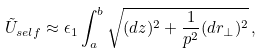Convert formula to latex. <formula><loc_0><loc_0><loc_500><loc_500>\tilde { U } _ { s e l f } \approx \epsilon _ { 1 } \int _ { a } ^ { b } \sqrt { ( d z ) ^ { 2 } + \frac { 1 } { p ^ { 2 } } ( d { r } _ { \perp } ) ^ { 2 } } \, ,</formula> 